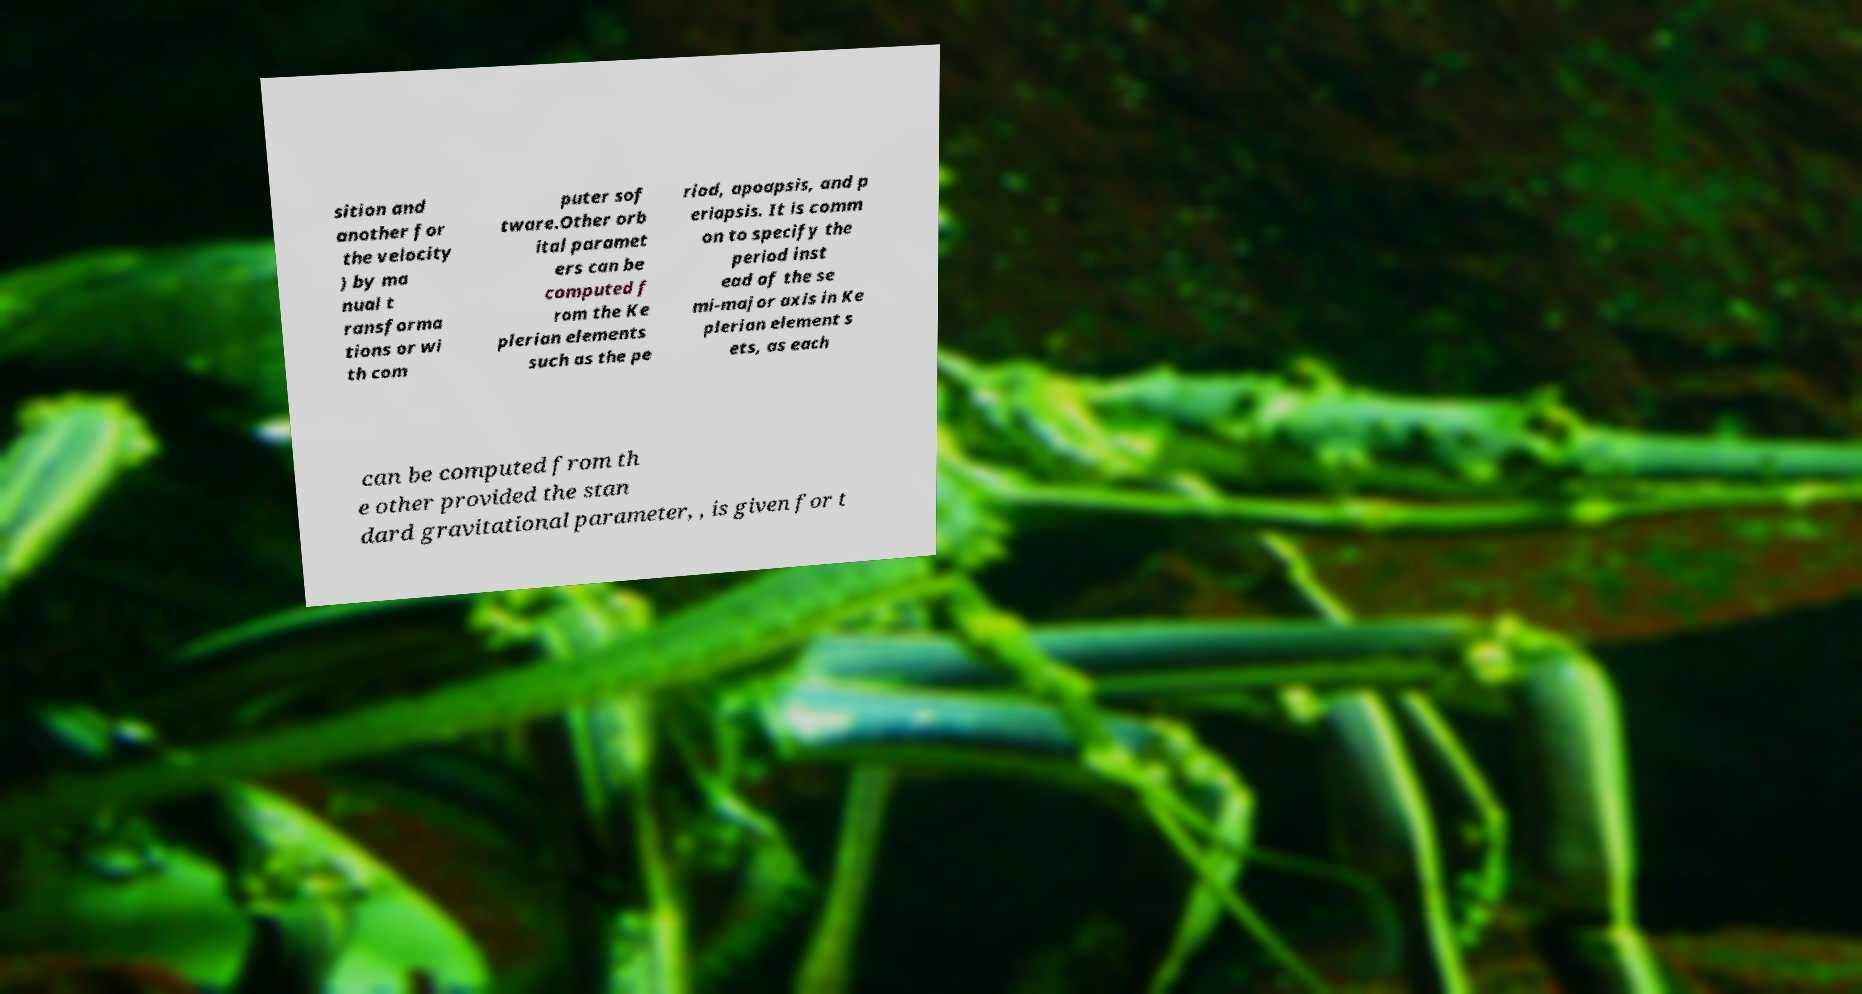Please read and relay the text visible in this image. What does it say? sition and another for the velocity ) by ma nual t ransforma tions or wi th com puter sof tware.Other orb ital paramet ers can be computed f rom the Ke plerian elements such as the pe riod, apoapsis, and p eriapsis. It is comm on to specify the period inst ead of the se mi-major axis in Ke plerian element s ets, as each can be computed from th e other provided the stan dard gravitational parameter, , is given for t 